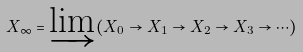Convert formula to latex. <formula><loc_0><loc_0><loc_500><loc_500>X _ { \infty } = \varinjlim ( X _ { 0 } \rightarrow X _ { 1 } \rightarrow X _ { 2 } \rightarrow X _ { 3 } \rightarrow \cdots )</formula> 